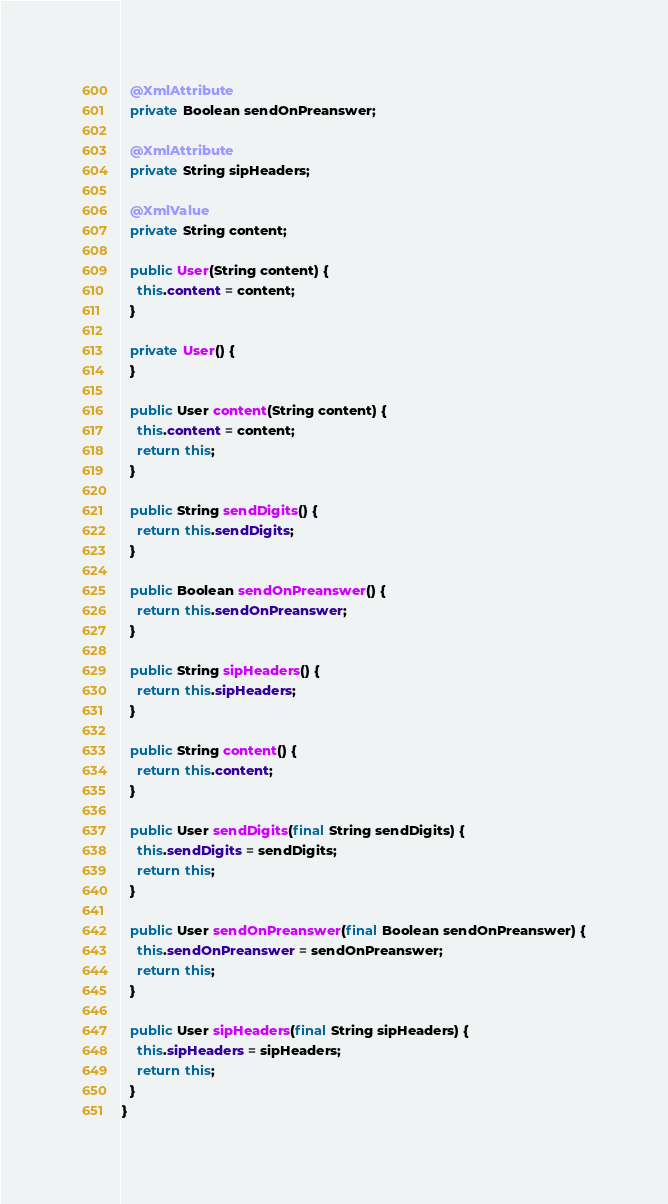<code> <loc_0><loc_0><loc_500><loc_500><_Java_>
  @XmlAttribute
  private Boolean sendOnPreanswer;

  @XmlAttribute
  private String sipHeaders;

  @XmlValue
  private String content;

  public User(String content) {
    this.content = content;
  }

  private User() {
  }

  public User content(String content) {
    this.content = content;
    return this;
  }

  public String sendDigits() {
    return this.sendDigits;
  }

  public Boolean sendOnPreanswer() {
    return this.sendOnPreanswer;
  }

  public String sipHeaders() {
    return this.sipHeaders;
  }

  public String content() {
    return this.content;
  }

  public User sendDigits(final String sendDigits) {
    this.sendDigits = sendDigits;
    return this;
  }

  public User sendOnPreanswer(final Boolean sendOnPreanswer) {
    this.sendOnPreanswer = sendOnPreanswer;
    return this;
  }

  public User sipHeaders(final String sipHeaders) {
    this.sipHeaders = sipHeaders;
    return this;
  }
}
</code> 